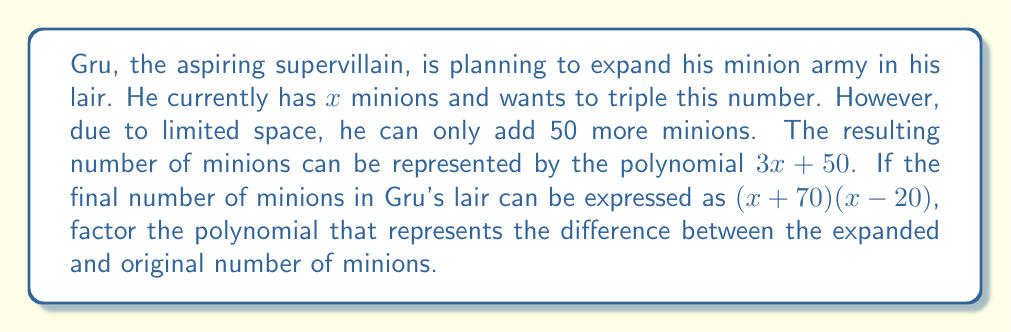Show me your answer to this math problem. Let's approach this step-by-step:

1) The expanded number of minions is represented by $3x + 50$.

2) The final number of minions is given by $(x + 70)(x - 20)$.

3) To find the difference, we need to subtract the original number of minions $(x)$ from the final number:

   $(x + 70)(x - 20) - x$

4) Let's expand $(x + 70)(x - 20)$:
   $x^2 + 70x - 20x - 1400 = x^2 + 50x - 1400$

5) Now our expression becomes:
   $(x^2 + 50x - 1400) - x$

6) Simplify:
   $x^2 + 49x - 1400$

7) This is the polynomial we need to factor. We can see that it's in the form $ax^2 + bx + c$ where:
   $a = 1$, $b = 49$, and $c = -1400$

8) To factor this, we need to find two numbers that multiply to give $ac = 1 \times (-1400) = -1400$ and add up to $b = 49$.

9) These numbers are 70 and -21.

10) So we can rewrite our polynomial as:
    $x^2 + 70x - 21x - 1400$

11) Grouping these terms:
    $(x^2 + 70x) + (-21x - 1400)$
    $x(x + 70) - 21(x + 70)$

12) Factoring out $(x + 70)$:
    $(x + 70)(x - 21)$

This is our factored polynomial.
Answer: $(x + 70)(x - 21)$ 